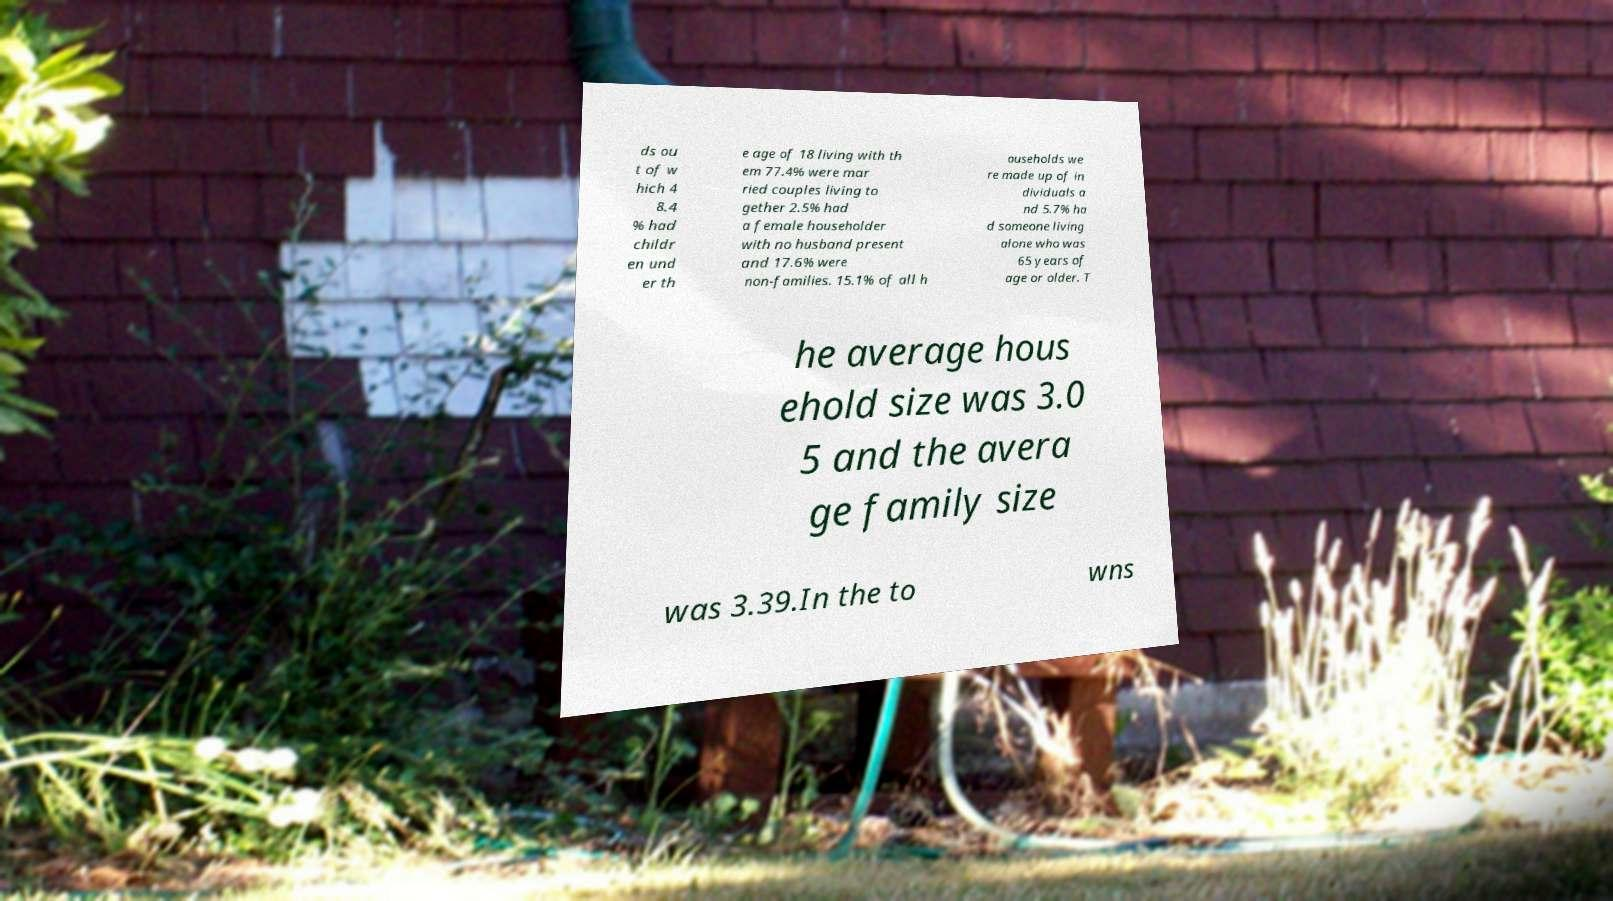For documentation purposes, I need the text within this image transcribed. Could you provide that? ds ou t of w hich 4 8.4 % had childr en und er th e age of 18 living with th em 77.4% were mar ried couples living to gether 2.5% had a female householder with no husband present and 17.6% were non-families. 15.1% of all h ouseholds we re made up of in dividuals a nd 5.7% ha d someone living alone who was 65 years of age or older. T he average hous ehold size was 3.0 5 and the avera ge family size was 3.39.In the to wns 